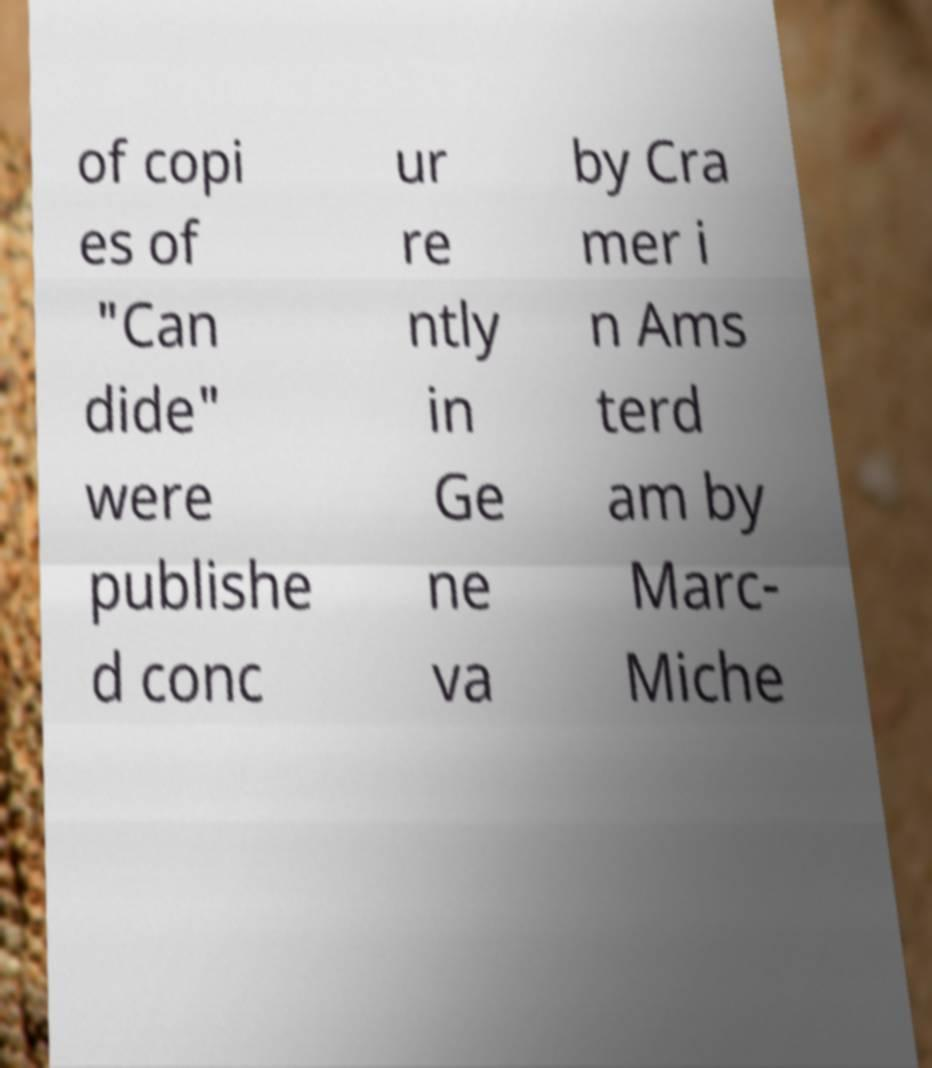What messages or text are displayed in this image? I need them in a readable, typed format. of copi es of "Can dide" were publishe d conc ur re ntly in Ge ne va by Cra mer i n Ams terd am by Marc- Miche 